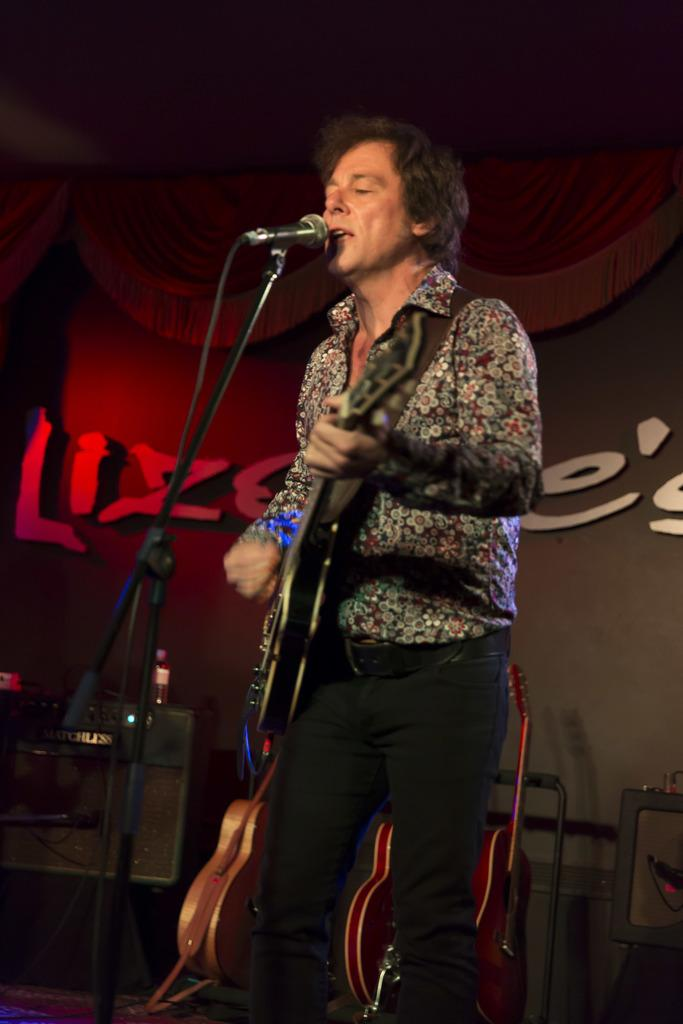What is the man in the image doing? The man is playing a guitar and singing on a mic. What is the man holding in his hands? The man is holding a guitar. Are there any other musical instruments visible in the image? Yes, there are musical instruments visible in the image. Can you tell me the position of the bat in the image? There is no bat present in the image. What type of sand can be seen in the image? There is no sand present in the image. 